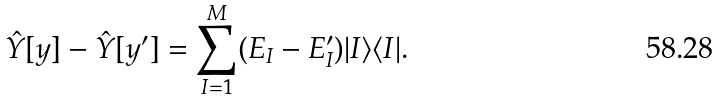<formula> <loc_0><loc_0><loc_500><loc_500>\hat { Y } [ y ] - \hat { Y } [ y ^ { \prime } ] = \sum _ { I = 1 } ^ { M } ( E _ { I } - E _ { I } ^ { \prime } ) | I \rangle \langle I | .</formula> 